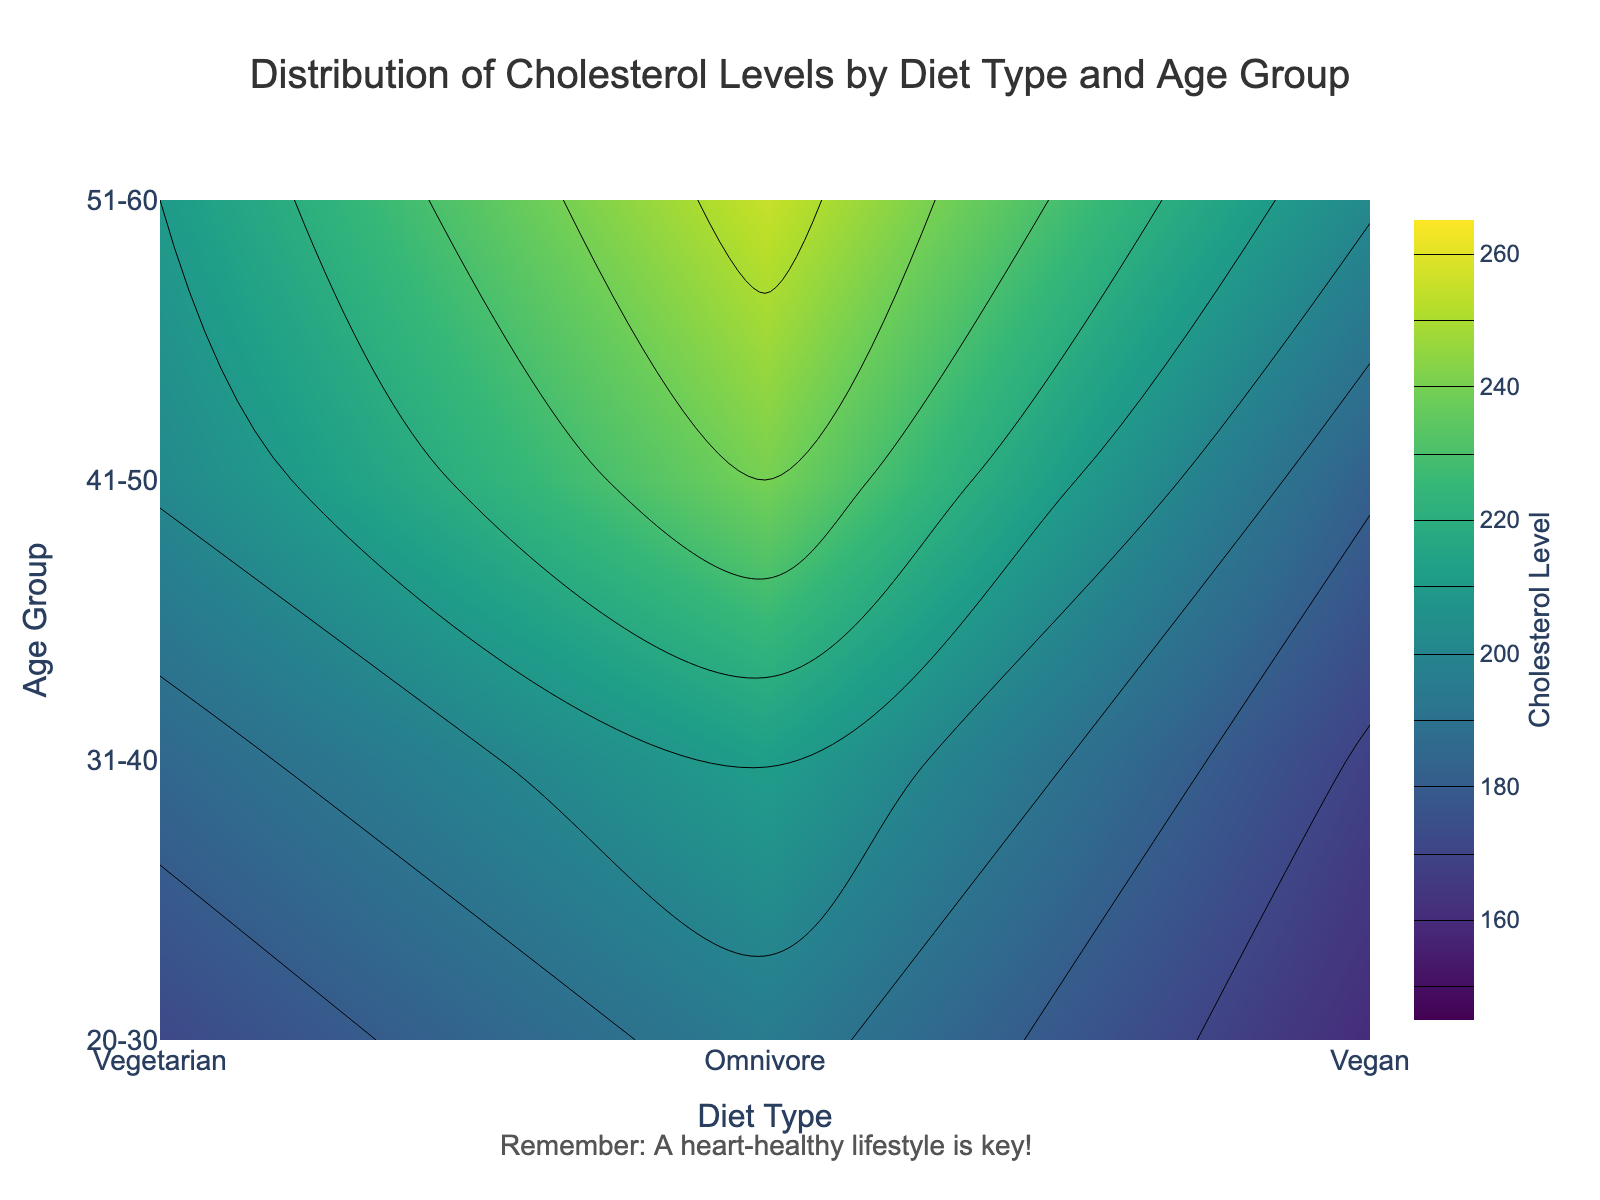What is the title of the plot? The title is located at the top of the figure and specifies what the figure represents.
Answer: Distribution of Cholesterol Levels by Diet Type and Age Group What are the diet types represented in the plot? The diet types are shown on the x-axis of the plot.
Answer: Vegetarian, Omnivore, Vegan What is the range of cholesterol levels shown on the color scale? The color scale indicates the range of cholesterol levels depicted in the plot.
Answer: 150 to 260 Which age group has the highest average cholesterol level for Omnivores? Find the highest point in the Omnivore column and locate the corresponding age group on the y-axis.
Answer: 51-60 Among the three diet types, which one shows the lowest average cholesterol levels across all age groups? Compare the average cholesterol levels for each diet type across the different age groups.
Answer: Vegan How does the average cholesterol level change with age for Vegetarians? Track the values in the Vegetarian column from the youngest to the oldest age group to observe the pattern.
Answer: The average cholesterol level increases with age Compare the average cholesterol level of 20-30 year-olds for Vegans and Omnivores. Which is higher? Look at the grayscale representation or color intensity at the intersection of 20-30 and the two diet types.
Answer: Omnivores Are there any age groups where the average cholesterol levels for Omnivores and Vegetarians are equal? Analyze the contour lines or color intensities to see if there are any points where values are the same for these two diet types across age groups.
Answer: No What does the annotation below the plot remind viewers to do? Notice the text written below the plot area as a note or reminder.
Answer: A heart-healthy lifestyle is key! What trend can be observed in cholesterol levels as age increases for Omnivores? Follow the contour lines in the Omnivore column from youngest to oldest age group to determine the trend.
Answer: Cholesterol levels increase with age 